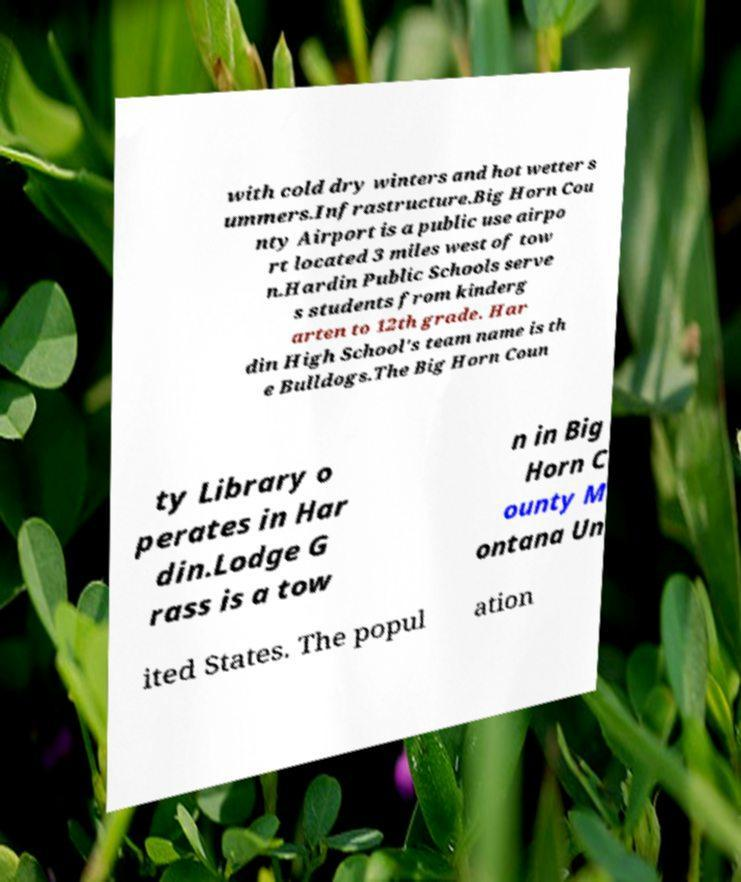Can you accurately transcribe the text from the provided image for me? with cold dry winters and hot wetter s ummers.Infrastructure.Big Horn Cou nty Airport is a public use airpo rt located 3 miles west of tow n.Hardin Public Schools serve s students from kinderg arten to 12th grade. Har din High School's team name is th e Bulldogs.The Big Horn Coun ty Library o perates in Har din.Lodge G rass is a tow n in Big Horn C ounty M ontana Un ited States. The popul ation 